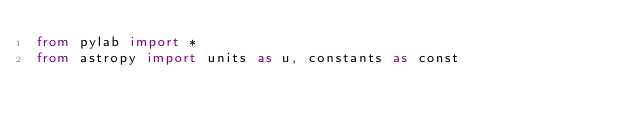Convert code to text. <code><loc_0><loc_0><loc_500><loc_500><_Python_>from pylab import *
from astropy import units as u, constants as const</code> 